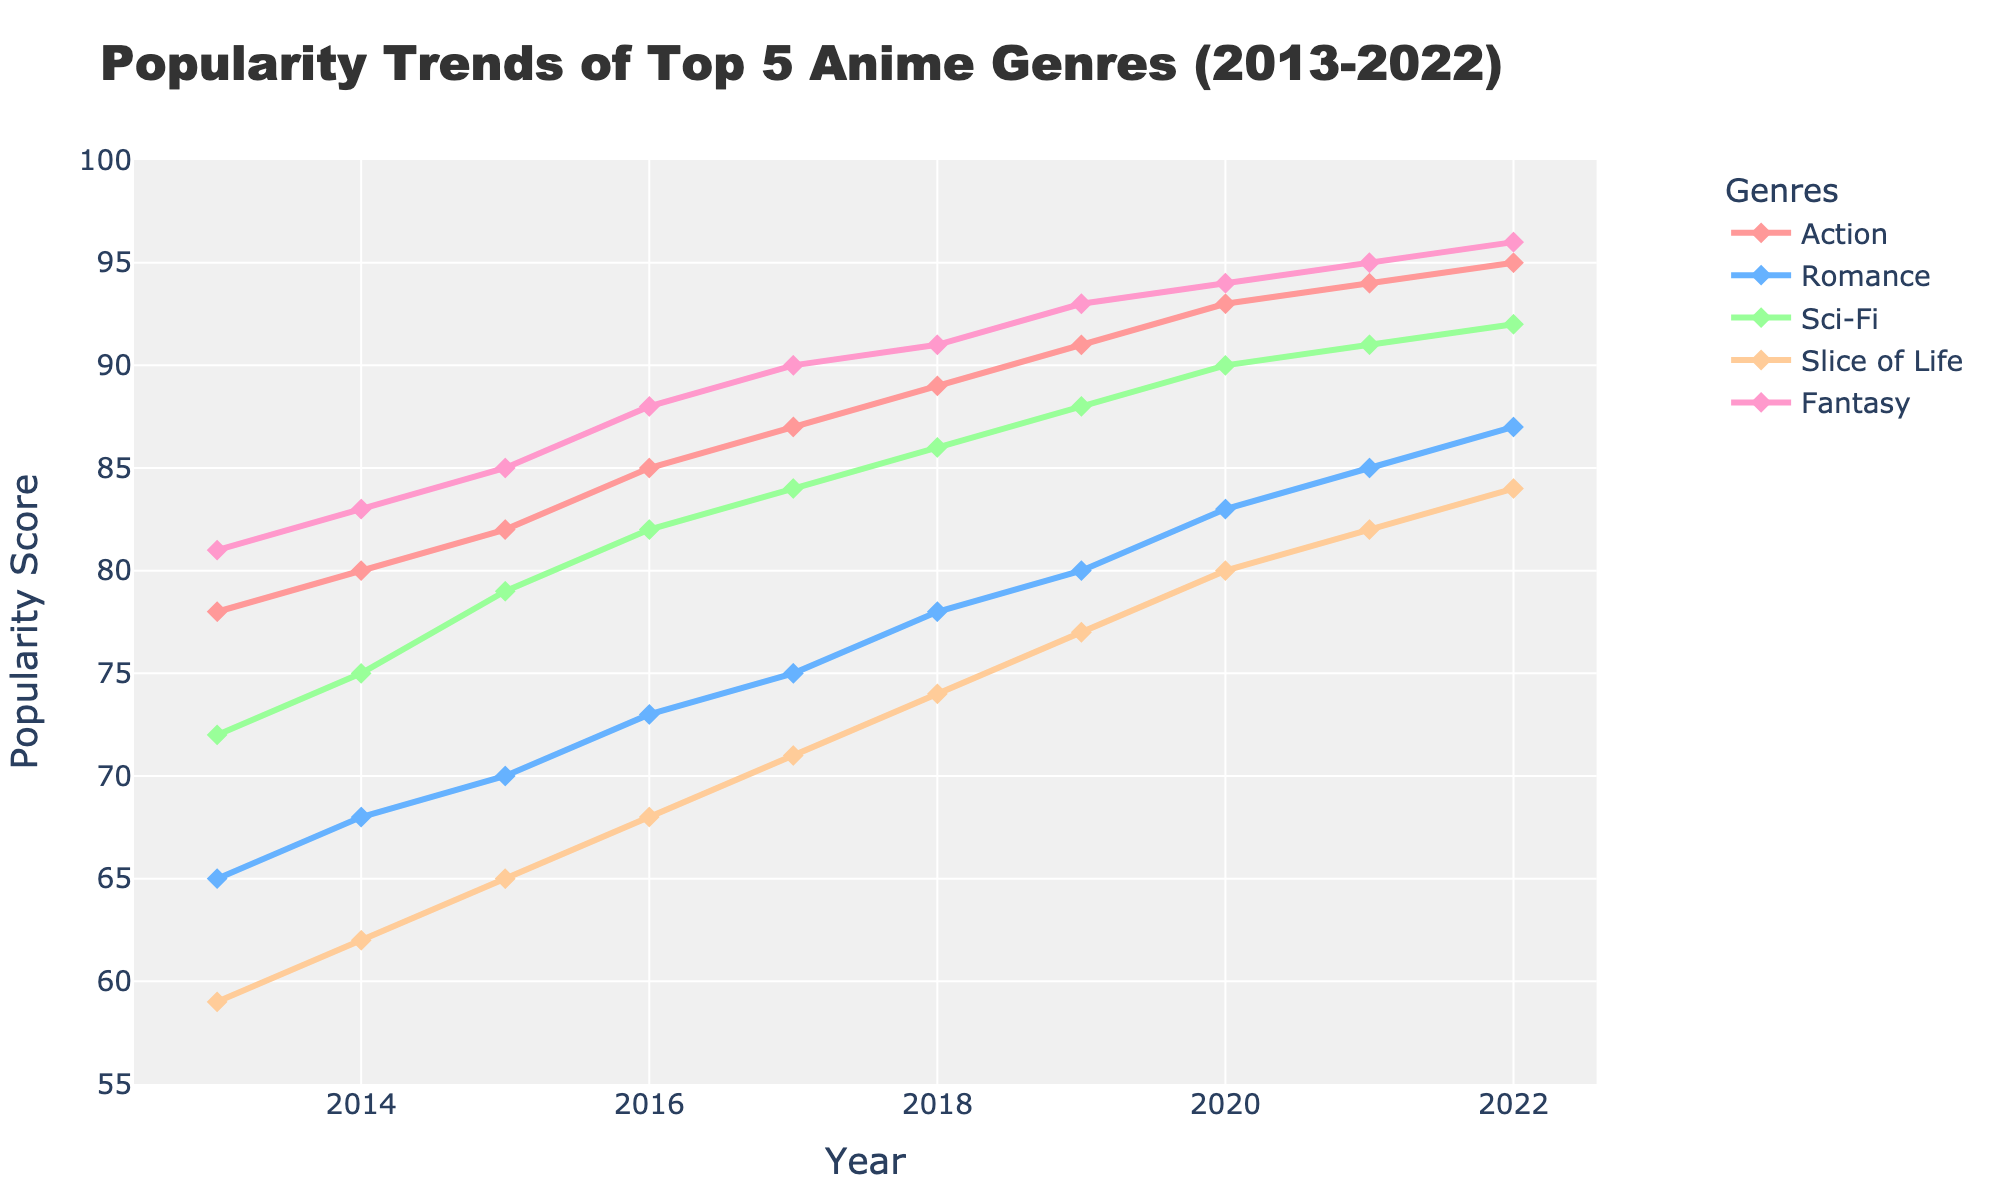Which genre had the highest popularity score in 2022? To find the highest popularity score in 2022, look at the values for each genre in that year. Fantasy has the highest value with a score of 96
Answer: Fantasy How did the popularity of Slice of Life change from 2013 to 2022? To see the change in popularity, subtract the 2013 value from the 2022 value for Slice of Life. The value went from 59 in 2013 to 84 in 2022, an increase of 25
Answer: Increased by 25 Which genre showed the most consistent increase in popularity over the decade? Examine the trend lines for each genre. The Fantasy genre is consistently increasing every year without any drops, indicating the most consistent growth
Answer: Fantasy In which year did Sci-Fi experience its largest single-year increase in popularity? Check the difference in popularity scores between consecutive years for Sci-Fi. The largest increase is between 2015 and 2016, where the value went from 79 to 82, an increase of 3
Answer: 2016 Compare the popularity of Action and Romance in 2020. Which one is more popular and by how much? Look at the values for Action and Romance in 2020. Action has a value of 93, while Romance has 83. Therefore, Action is more popular by 10 points
Answer: Action by 10 points Which genre had the lowest popularity score in 2017 and what was the score? Check the scores for each genre in 2017. Slice of Life has the lowest score with a value of 71
Answer: Slice of Life, 71 What is the average popularity score of Romance over the decade shown in the graph? Sum all the yearly values for Romance (65 + 68 + 70 + 73 + 75 + 78 + 80 + 83 + 85 + 87) and divide by the number of years (10). The sum is 764, so the average is 764 / 10 = 76.4
Answer: 76.4 How many genres surpassed a popularity score of 90 in 2022? In 2022, look at the popularity scores for all genres. Action, Sci-Fi, Fantasy all have scores above 90. Thus, 3 genres surpassed 90
Answer: 3 What's the difference between the highest and the lowest popularity score across all genres in 2016? Identify the highest and lowest scores in 2016. Fantasy has the highest score (88), and Slice of Life has the lowest (68). The difference is 88 - 68 = 20
Answer: 20 